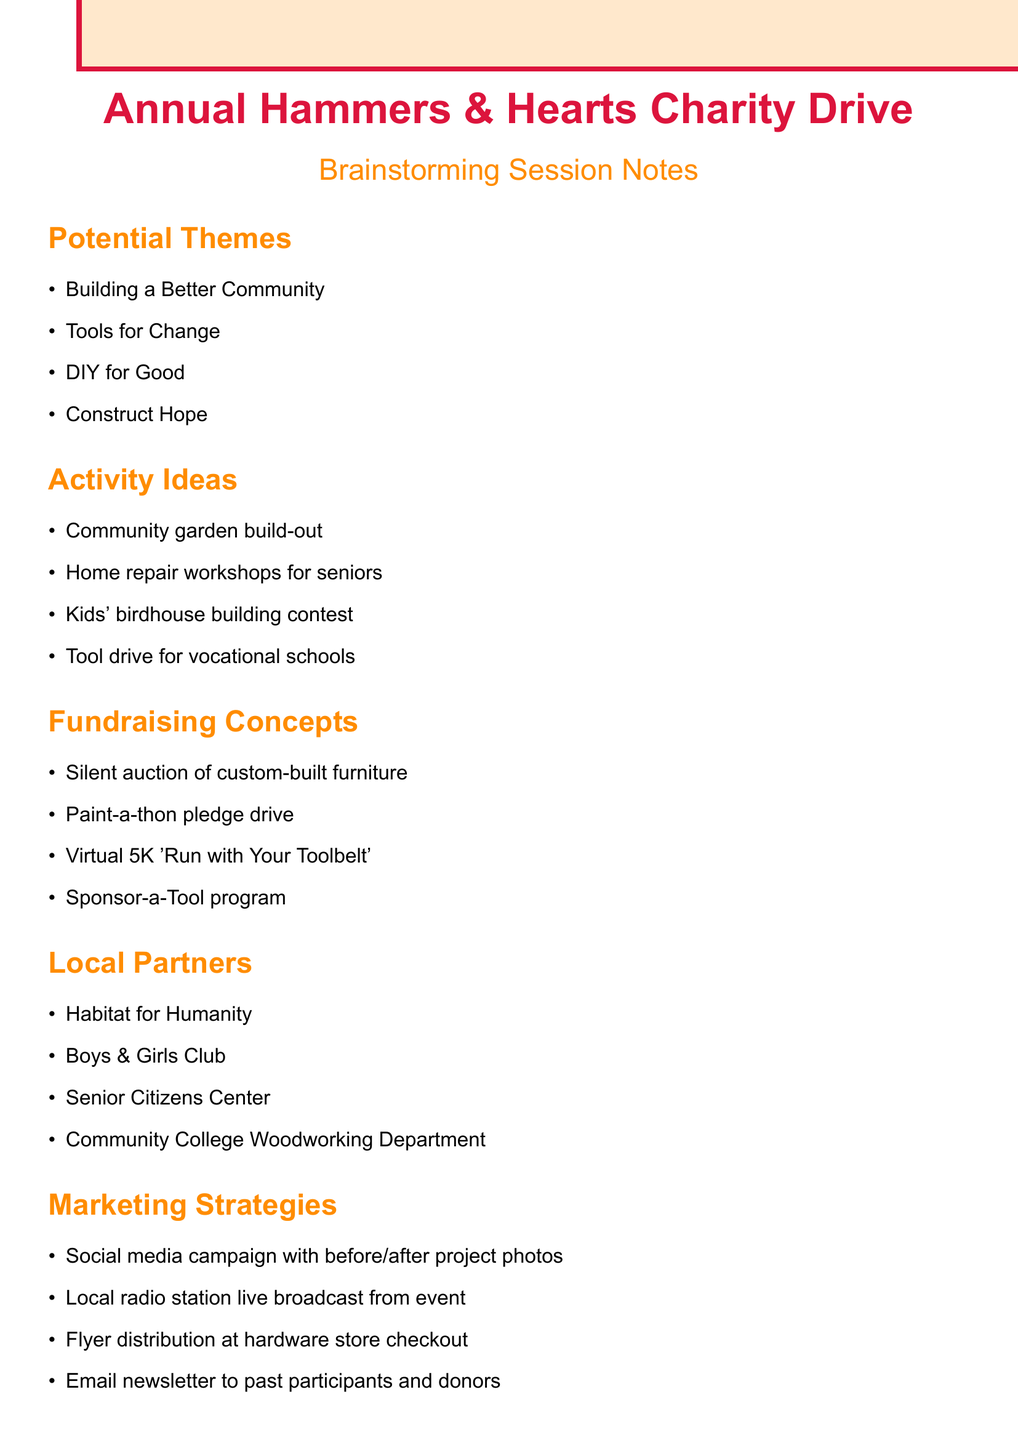What is the event title? The event title is stated at the beginning of the document.
Answer: Annual Hammers & Hearts Charity Drive What is one theme suggested for the event? The document lists several potential themes under the section "Potential Themes."
Answer: Building a Better Community Name one activity idea for the charity event. The document provides a list of possible activities under "Activity Ideas."
Answer: Community garden build-out What is one fundraising concept mentioned? The document includes various fundraising concepts in the "Fundraising Concepts" section.
Answer: Silent auction of custom-built furniture Who is one local partner listed? The document enumerates local partners under the "Local Partners" heading.
Answer: Habitat for Humanity What is the proposed event date? The document provides logistics details, including the event date.
Answer: Late spring Where is the venue for the event? The venue information is specified under "Logistics Considerations" in the document.
Answer: Hardware store parking lot and adjacent park What marketing strategy involves social media? The document describes several marketing strategies, including a mention of social media.
Answer: Social media campaign with before/after project photos What type of insurance is mentioned for activities? The document highlights liability insurance as a requirement for hands-on activities.
Answer: Liability insurance What is one reason for choosing the event date? The document mentions allowing for outdoor activities as a reason for the event date.
Answer: Outdoor activities 